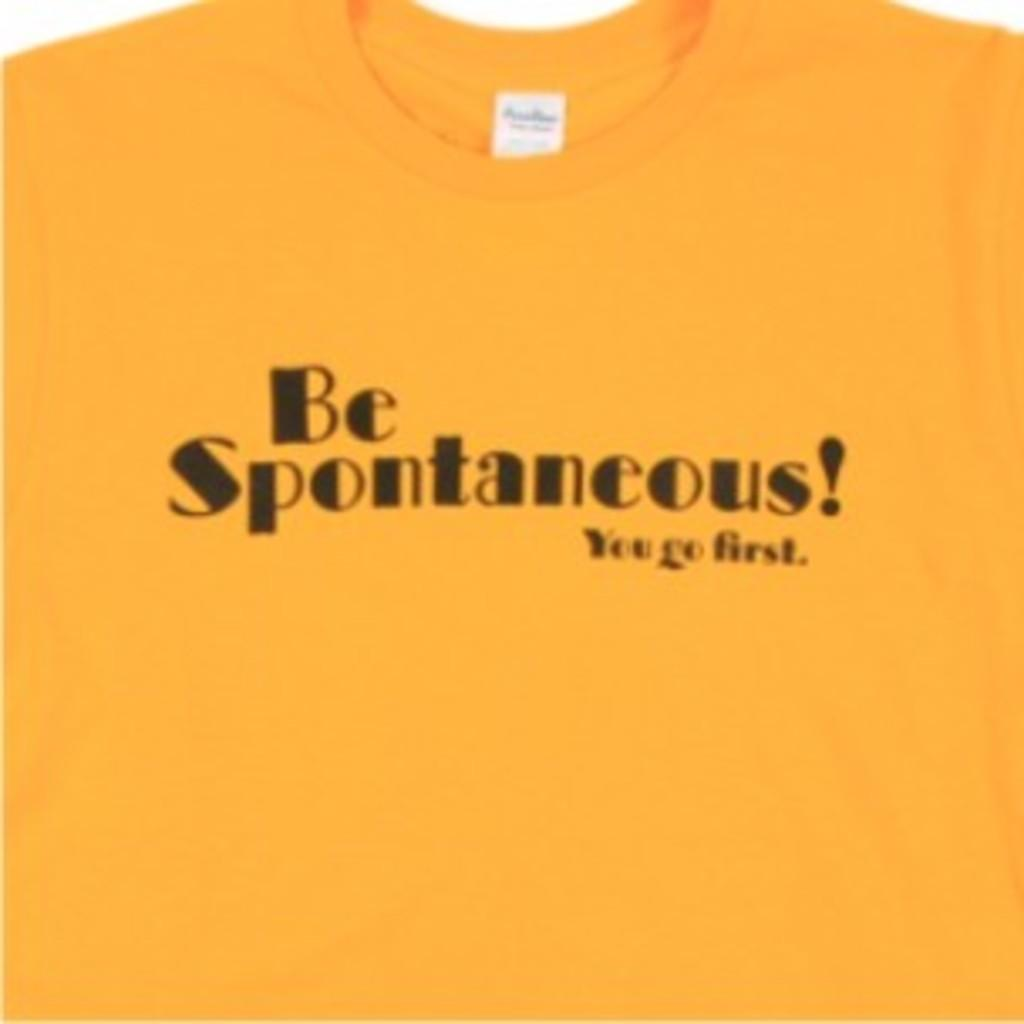What color is the T-shirt in the image? The T-shirt in the image is yellow. What is written on the T-shirt? The phrase "BE SPONTANEOUS! YOU GO FIRST" is written on the T-shirt. How many babies are wearing a vest in the image? There are no babies or vests present in the image; it only features a yellow T-shirt with a phrase written on it. 